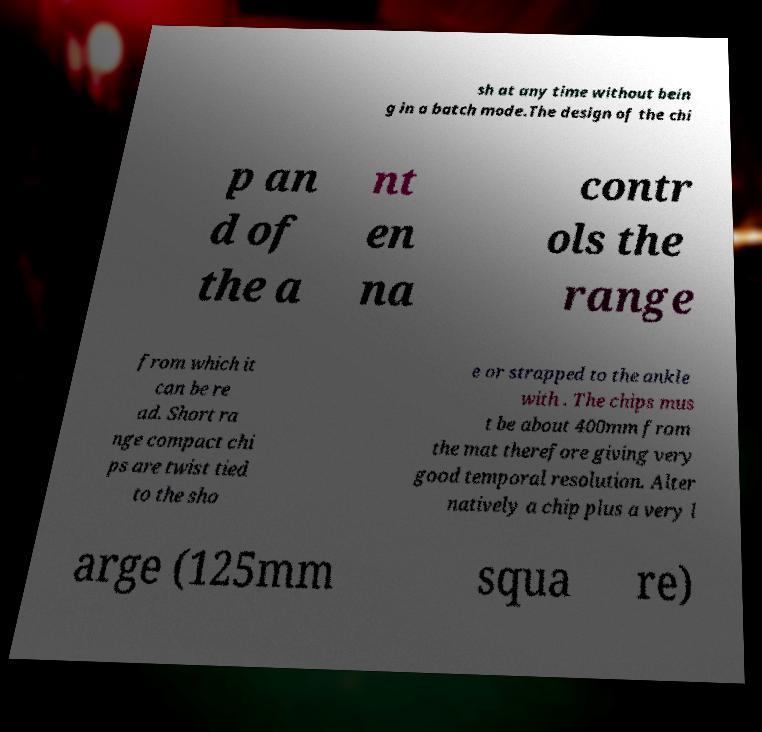I need the written content from this picture converted into text. Can you do that? sh at any time without bein g in a batch mode.The design of the chi p an d of the a nt en na contr ols the range from which it can be re ad. Short ra nge compact chi ps are twist tied to the sho e or strapped to the ankle with . The chips mus t be about 400mm from the mat therefore giving very good temporal resolution. Alter natively a chip plus a very l arge (125mm squa re) 